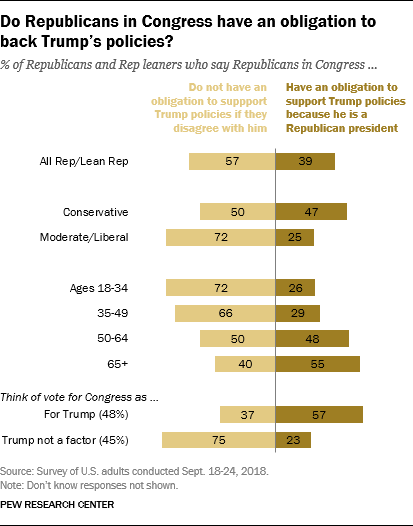Draw attention to some important aspects in this diagram. The value of the last left bar is 75. 